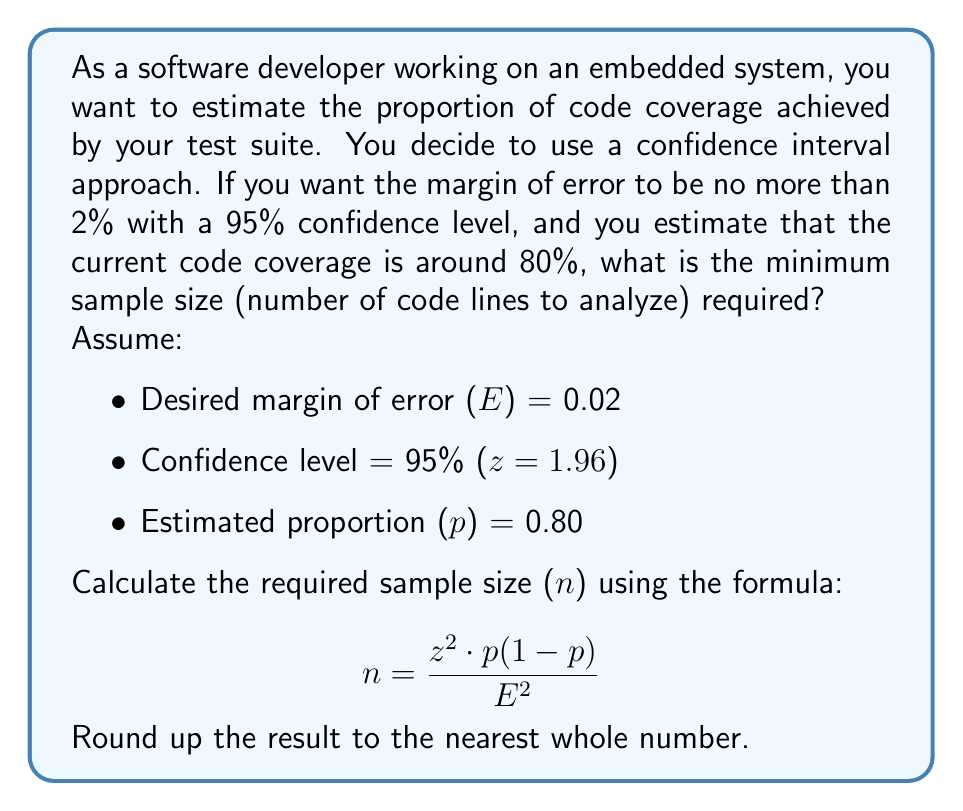Could you help me with this problem? To calculate the required sample size, we'll use the formula for sample size determination when estimating a proportion:

$$ n = \frac{z^2 \cdot p(1-p)}{E^2} $$

Where:
- n = required sample size
- z = z-score for the desired confidence level (1.96 for 95% confidence)
- p = estimated proportion (0.80 for 80% code coverage)
- E = desired margin of error (0.02 for 2%)

Let's substitute the values:

$$ n = \frac{1.96^2 \cdot 0.80(1-0.80)}{0.02^2} $$

Now, let's solve step-by-step:

1. Calculate $1.96^2$:
   $1.96^2 = 3.8416$

2. Calculate $0.80(1-0.80)$:
   $0.80 \cdot 0.20 = 0.16$

3. Calculate $0.02^2$:
   $0.02^2 = 0.0004$

4. Multiply the numerator:
   $3.8416 \cdot 0.16 = 0.614656$

5. Divide by the denominator:
   $\frac{0.614656}{0.0004} = 1536.64$

6. Round up to the nearest whole number:
   $1537$

Therefore, the minimum sample size required is 1,537 lines of code to analyze.
Answer: 1,537 lines of code 